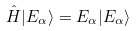Convert formula to latex. <formula><loc_0><loc_0><loc_500><loc_500>\hat { H } | E _ { \alpha } \rangle = E _ { \alpha } | E _ { \alpha } \rangle</formula> 